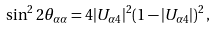<formula> <loc_0><loc_0><loc_500><loc_500>\sin ^ { 2 } 2 \theta _ { \alpha \alpha } = 4 | U _ { \alpha 4 } | ^ { 2 } ( 1 - | U _ { \alpha 4 } | ) ^ { 2 } \, ,</formula> 